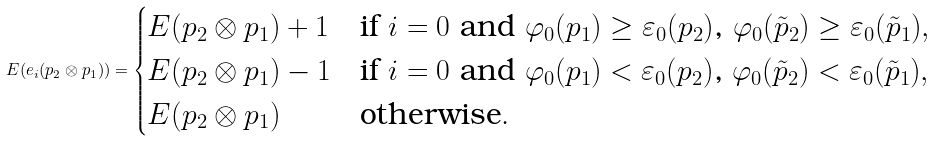<formula> <loc_0><loc_0><loc_500><loc_500>E ( e _ { i } ( p _ { 2 } \otimes p _ { 1 } ) ) = \begin{cases} E ( p _ { 2 } \otimes p _ { 1 } ) + 1 & \text {if $i=0$ and $\varphi_{0}(p_{1})\geq \varepsilon_{0}(p_{2})$, $\varphi_{0}(\tilde{p}_{2})\geq \varepsilon_{0}(\tilde{p}_{1})$} , \\ E ( p _ { 2 } \otimes p _ { 1 } ) - 1 & \text {if $i=0$ and $\varphi_{0}(p_{1})< \varepsilon_{0}(p_{2})$, $\varphi_{0}(\tilde{p}_{2})<\varepsilon_{0}(\tilde{p}_{1})$} , \\ E ( p _ { 2 } \otimes p _ { 1 } ) & \text {otherwise} . \end{cases}</formula> 